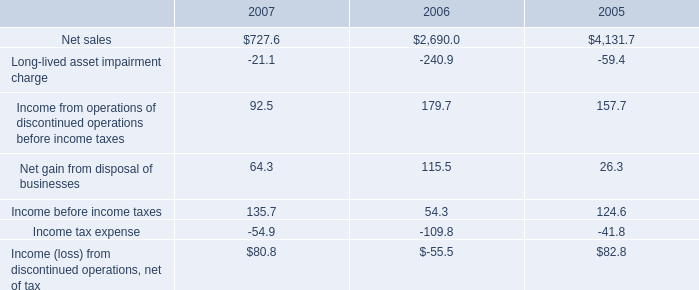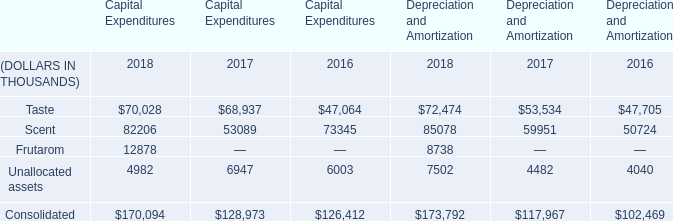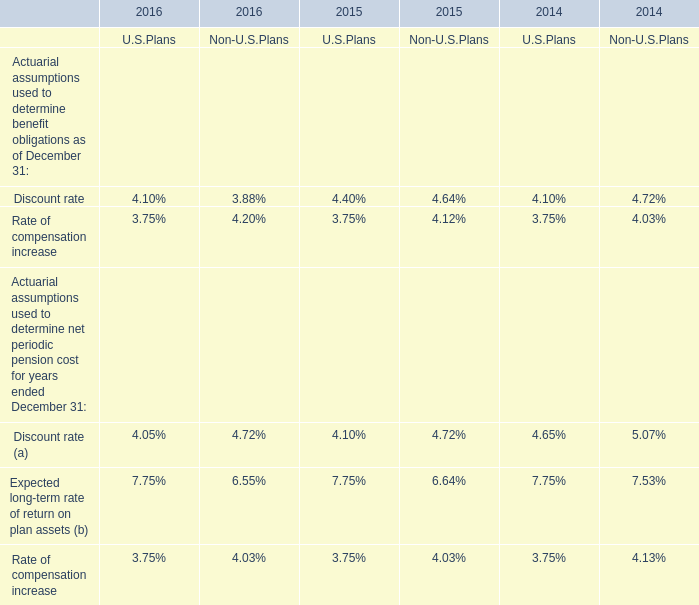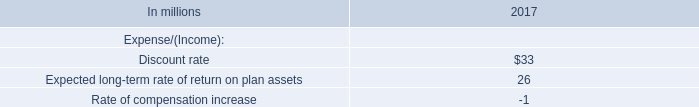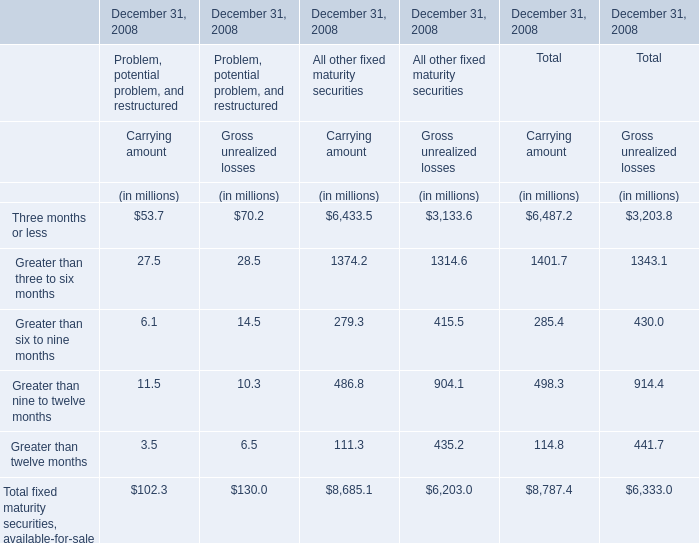for the 3 years ended 2007 income ( loss ) from discontinued operations net of tax totaled? 
Computations: ((80.8 + 82.8) - 55.5)
Answer: 108.1. 